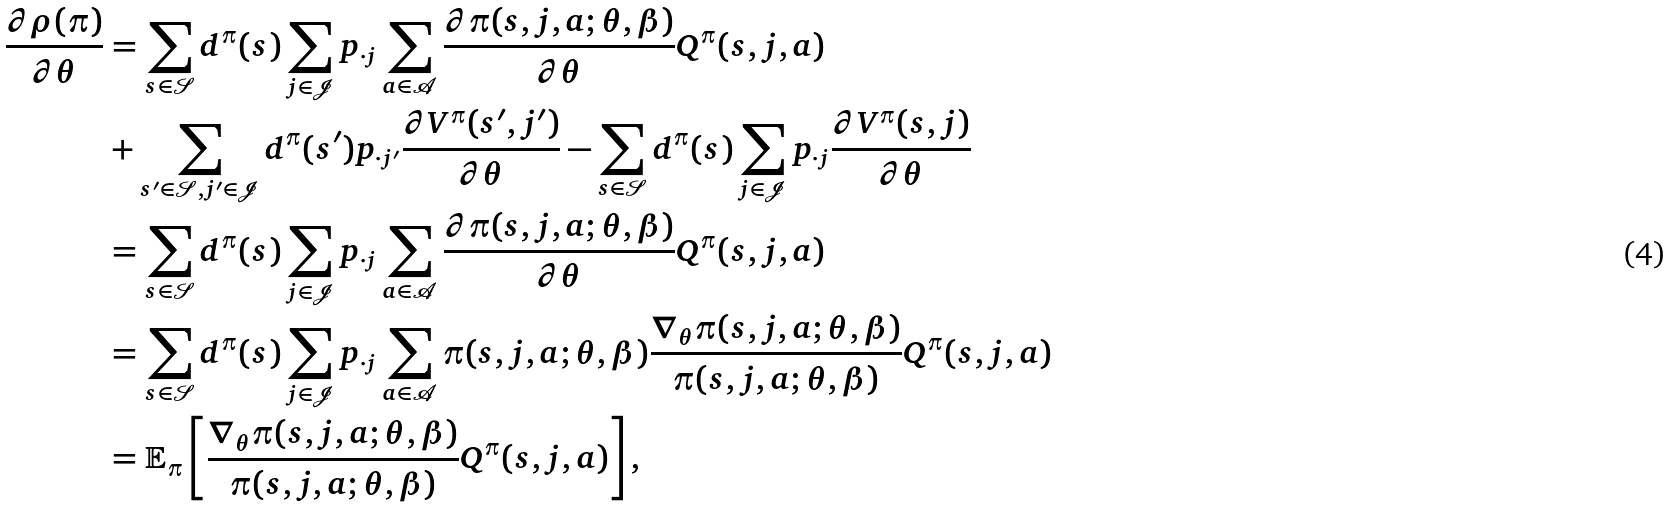Convert formula to latex. <formula><loc_0><loc_0><loc_500><loc_500>\frac { \partial \rho ( \pi ) } { \partial \theta } & = \sum _ { s \in \mathcal { S } } d ^ { \pi } ( s ) \sum _ { j \in \mathcal { J } } p _ { \cdot j } \sum _ { a \in \mathcal { A } } \frac { \partial \pi ( s , j , a ; \theta , \beta ) } { \partial \theta } Q ^ { \pi } ( s , j , a ) \\ & + \sum _ { s ^ { \prime } \in \mathcal { S } , j ^ { \prime } \in \mathcal { J } } d ^ { \pi } ( s ^ { \prime } ) p _ { \cdot j ^ { \prime } } \frac { \partial V ^ { \pi } ( s ^ { \prime } , j ^ { \prime } ) } { \partial \theta } - \sum _ { s \in \mathcal { S } } d ^ { \pi } ( s ) \sum _ { j \in \mathcal { J } } p _ { \cdot j } \frac { \partial V ^ { \pi } ( s , j ) } { \partial \theta } \\ & = \sum _ { s \in \mathcal { S } } d ^ { \pi } ( s ) \sum _ { j \in \mathcal { J } } p _ { \cdot j } \sum _ { a \in \mathcal { A } } \frac { \partial \pi ( s , j , a ; \theta , \beta ) } { \partial \theta } Q ^ { \pi } ( s , j , a ) \\ & = \sum _ { s \in \mathcal { S } } d ^ { \pi } ( s ) \sum _ { j \in \mathcal { J } } p _ { \cdot j } \sum _ { a \in \mathcal { A } } \pi ( s , j , a ; \theta , \beta ) \frac { \nabla _ { \theta } \pi ( s , j , a ; \theta , \beta ) } { \pi ( s , j , a ; \theta , \beta ) } Q ^ { \pi } ( s , j , a ) \\ & = \mathbb { E } _ { \pi } \left [ \frac { \nabla _ { \theta } \pi ( s , j , a ; \theta , \beta ) } { \pi ( s , j , a ; \theta , \beta ) } Q ^ { \pi } ( s , j , a ) \right ] ,</formula> 